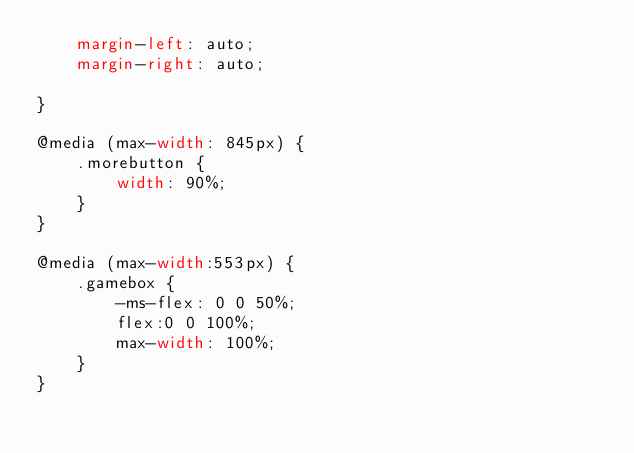<code> <loc_0><loc_0><loc_500><loc_500><_CSS_>    margin-left: auto;
    margin-right: auto;

}

@media (max-width: 845px) {
    .morebutton {
        width: 90%;
    }
}

@media (max-width:553px) {
    .gamebox {
        -ms-flex: 0 0 50%;
        flex:0 0 100%;
        max-width: 100%;
    }
}



</code> 